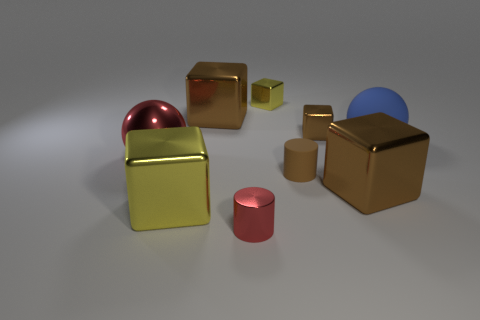There is another object that is the same shape as the big red shiny thing; what is its size?
Make the answer very short. Large. Is the number of tiny red objects in front of the tiny brown matte cylinder greater than the number of big brown metallic objects left of the big yellow block?
Offer a terse response. Yes. Do the large yellow thing and the brown cube to the left of the small yellow object have the same material?
Offer a terse response. Yes. Are there any other things that are the same shape as the big yellow thing?
Your answer should be very brief. Yes. There is a small thing that is both behind the small brown cylinder and right of the small yellow metal block; what is its color?
Provide a short and direct response. Brown. There is a red metal object that is on the left side of the red cylinder; what is its shape?
Your response must be concise. Sphere. There is a rubber cylinder left of the big sphere right of the tiny rubber object in front of the blue matte ball; how big is it?
Your answer should be very brief. Small. There is a big brown object behind the tiny brown rubber cylinder; how many red cylinders are left of it?
Keep it short and to the point. 0. How big is the brown metallic object that is right of the tiny brown rubber cylinder and behind the large red metal thing?
Provide a succinct answer. Small. How many metallic objects are brown cylinders or yellow cylinders?
Provide a short and direct response. 0. 